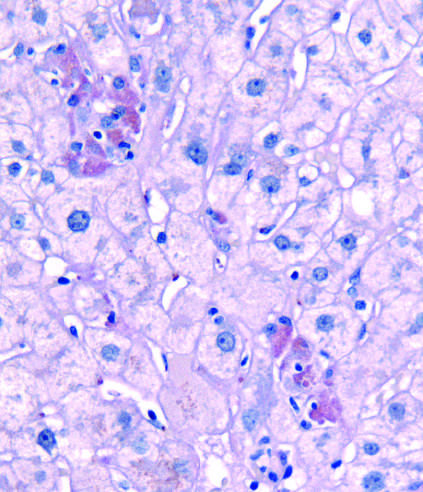does a crypt abscess stain after diastase digestion?
Answer the question using a single word or phrase. No 